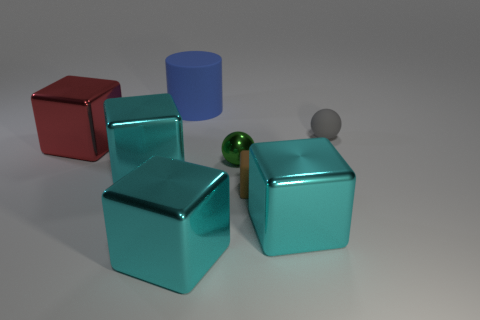Is there a big cyan metal cube that is behind the tiny ball in front of the tiny rubber object that is to the right of the brown rubber cube?
Ensure brevity in your answer.  No. What is the size of the gray matte thing?
Your answer should be compact. Small. There is a gray matte sphere behind the tiny green ball; what is its size?
Your answer should be compact. Small. There is a ball that is behind the red shiny block; is it the same size as the tiny brown cube?
Make the answer very short. Yes. Is there anything else that is the same color as the small shiny object?
Keep it short and to the point. No. There is a tiny green thing; what shape is it?
Your response must be concise. Sphere. How many big things are behind the brown matte object and in front of the small gray sphere?
Your response must be concise. 2. Does the large rubber cylinder have the same color as the small matte sphere?
Provide a short and direct response. No. What material is the small green object that is the same shape as the gray rubber thing?
Offer a terse response. Metal. Are there the same number of big cyan cubes behind the gray ball and cubes to the right of the tiny green shiny sphere?
Your answer should be very brief. No. 